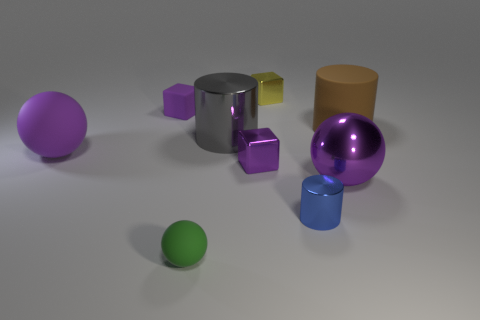Add 1 big metal objects. How many objects exist? 10 Subtract all balls. How many objects are left? 6 Add 8 small purple rubber cubes. How many small purple rubber cubes exist? 9 Subtract 0 brown blocks. How many objects are left? 9 Subtract all big cyan shiny cubes. Subtract all purple rubber spheres. How many objects are left? 8 Add 9 tiny green rubber objects. How many tiny green rubber objects are left? 10 